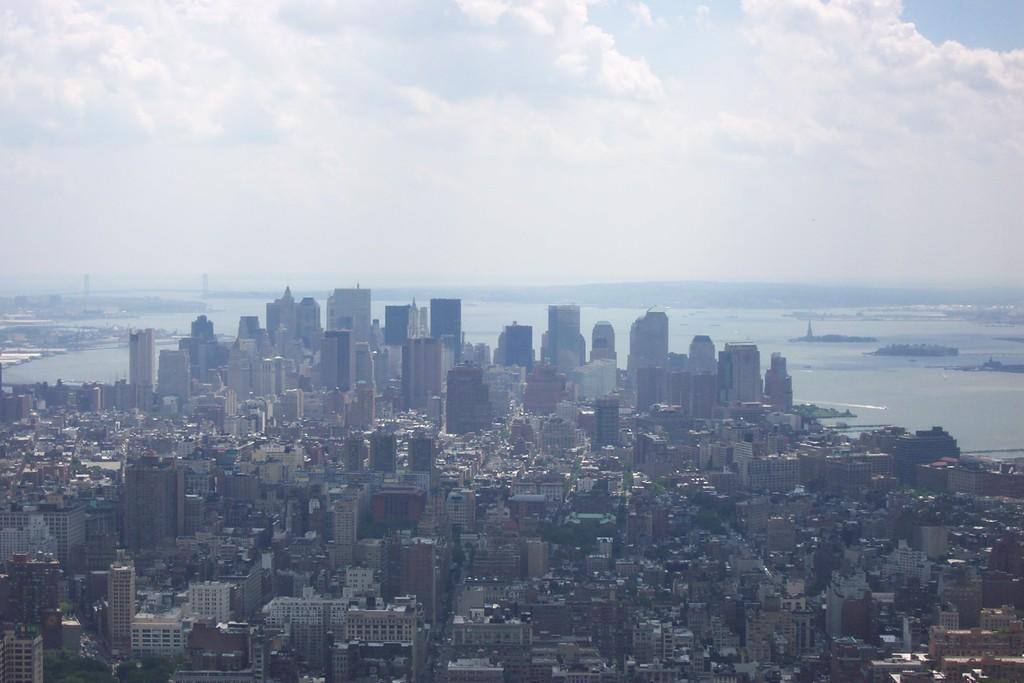Could you give a brief overview of what you see in this image? In this image I can see number of buildings and trees. In the background I can see some water and the sky. 